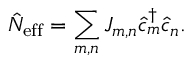Convert formula to latex. <formula><loc_0><loc_0><loc_500><loc_500>\hat { N } _ { e f f } = \sum _ { m , n } J _ { m , n } \hat { c } _ { m } ^ { \dagger } \hat { c } _ { n } .</formula> 